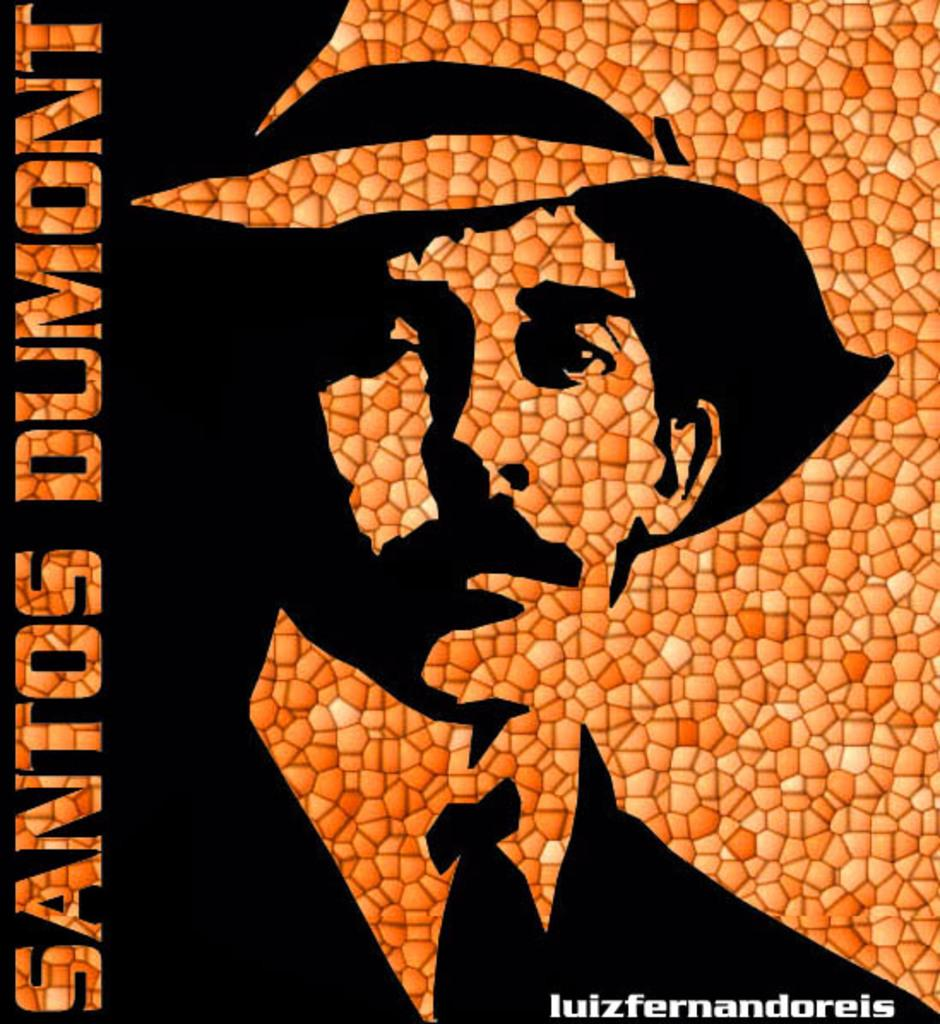Provide a one-sentence caption for the provided image. An ad or poster of santos dumont, his pictures seems to be made using different textures. 